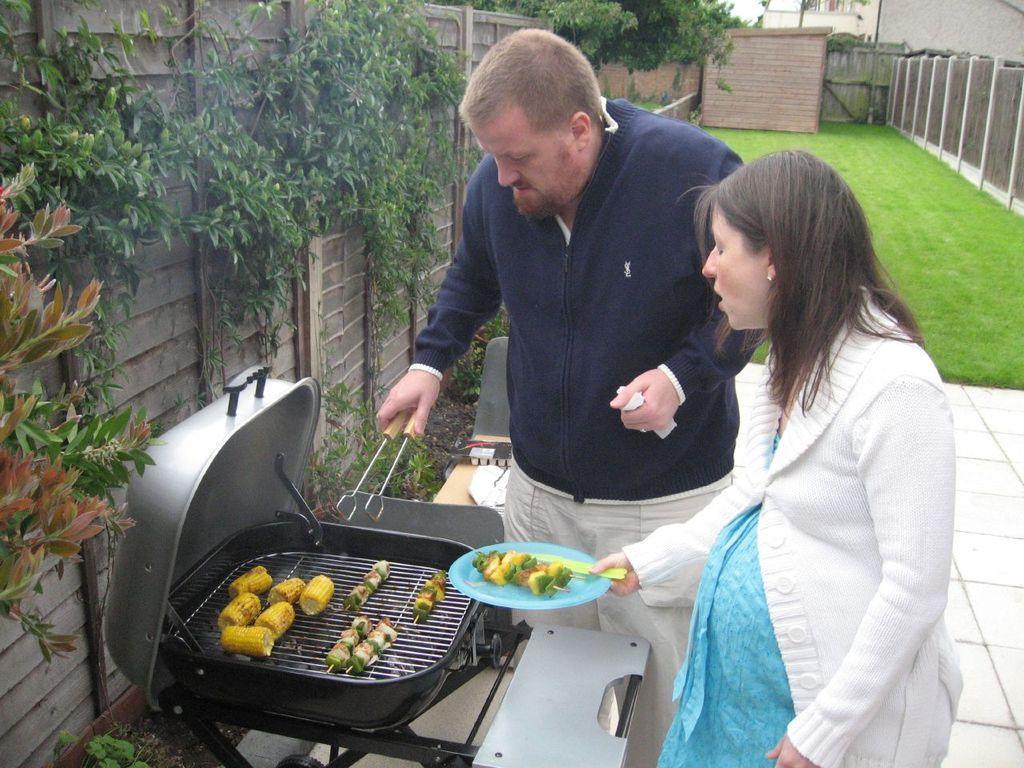Describe this image in one or two sentences. In this image we can see food on the barbecue, man holding tongs and a woman holding serving plate. In the background we can see ground, walls, creepers, trees and floor. 